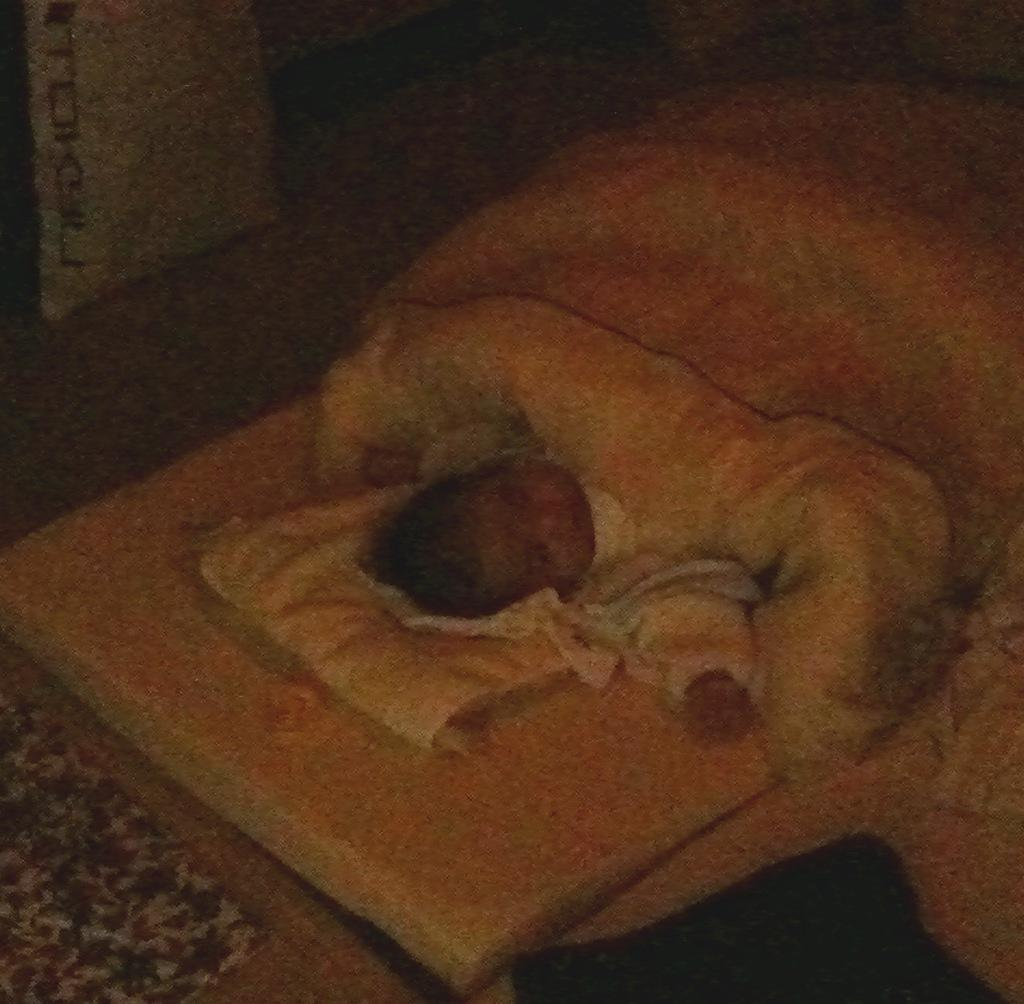What is the main subject of the image? There is a baby in the image. What else can be seen in the image besides the baby? There are clothes and some objects in the image. Can you describe the background of the image? The background of the image is blurry. What is the baby's income in the image? The baby's income cannot be determined from the image, as babies do not have income. 